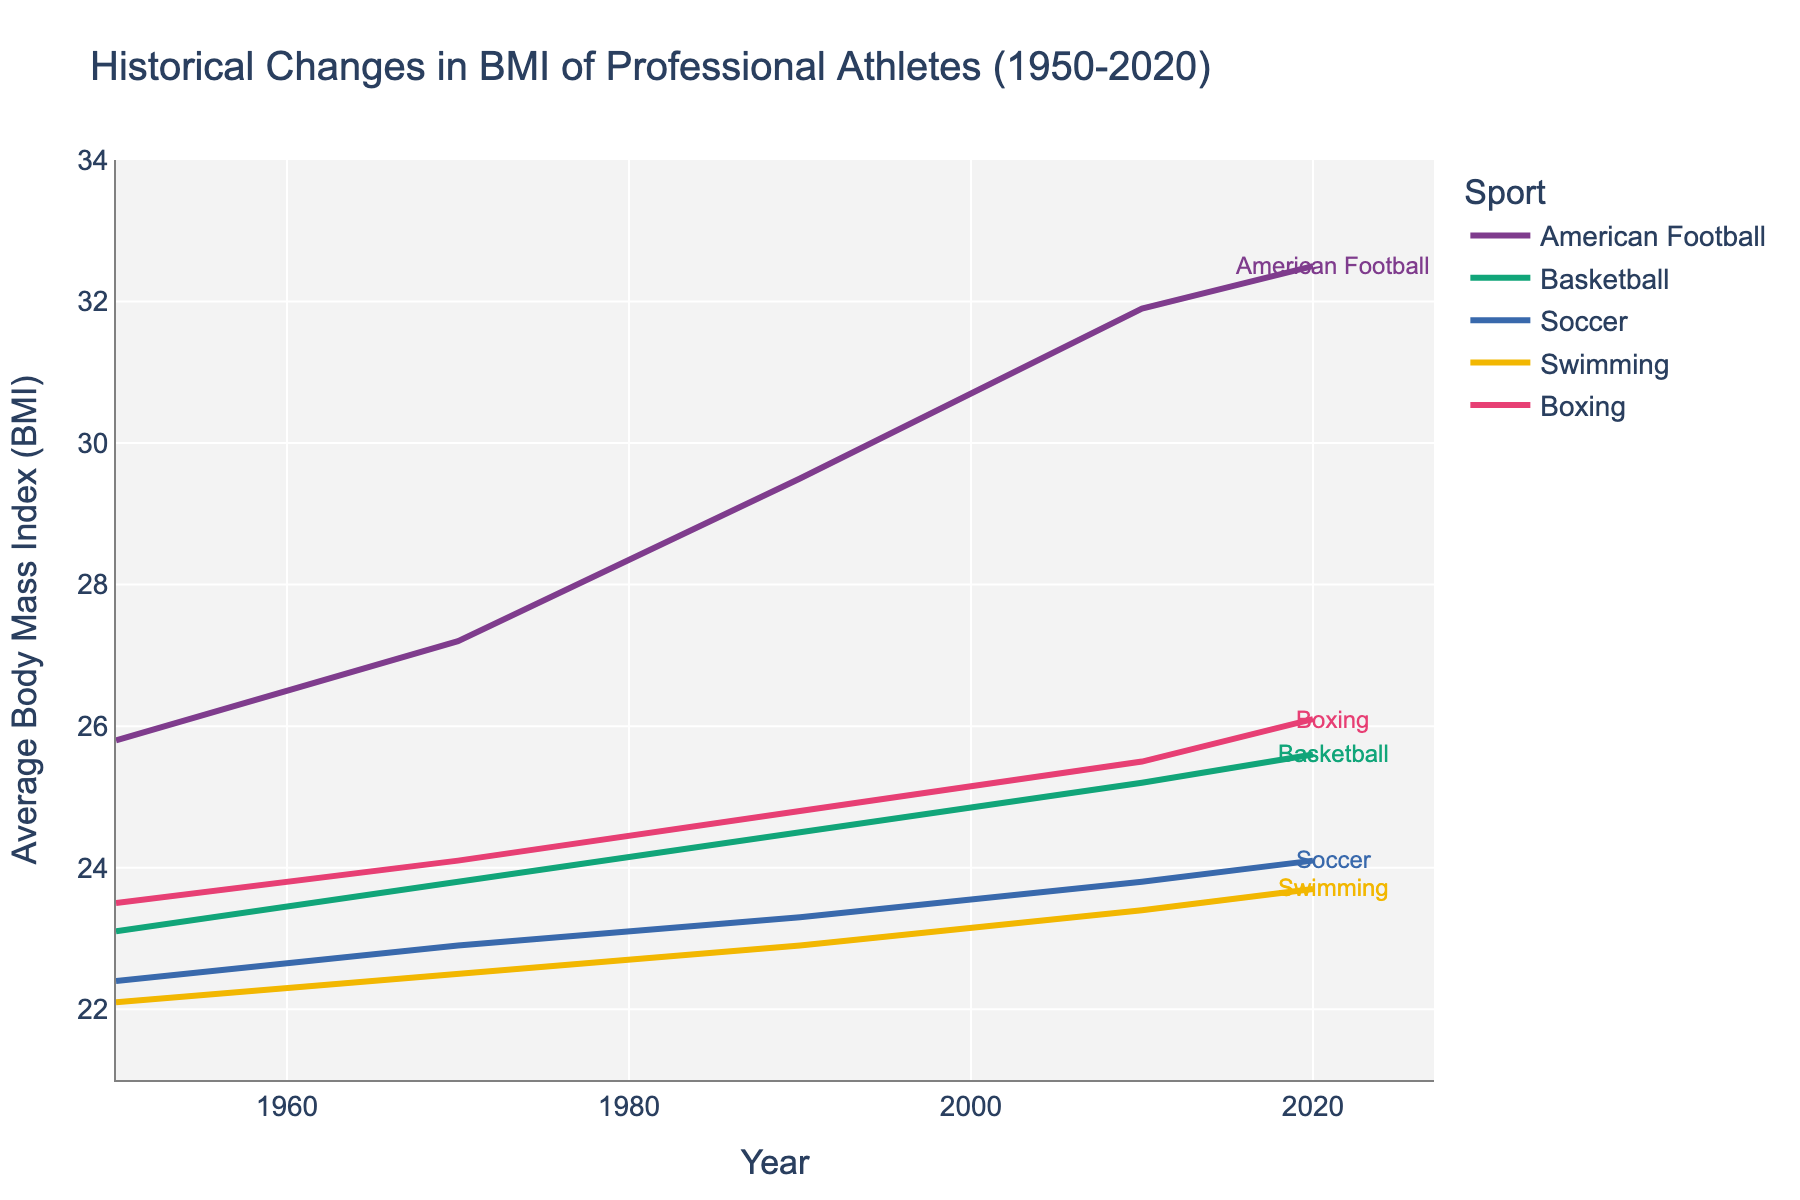What's the sport with the highest average BMI in 2020? To find the sport with the highest average BMI in 2020, follow the line for each sport to the year 2020 and compare the values. American Football has the highest BMI.
Answer: American Football How did the average BMI of professional boxers change from 1950 to 2020? Look at the points for Boxing in 1950 and 2020 and find the difference. The value increases from 23.5 in 1950 to 26.1 in 2020, so the change is 26.1 - 23.5 = 2.6.
Answer: 2.6 Which sport had the smallest increase in average BMI from 1950 to 2020? Calculate the increase for each sport by subtracting the 1950 BMI from the 2020 BMI. Swimming has the smallest increase (23.7 - 22.1 = 1.6).
Answer: Swimming Compare the basketball and soccer average BMIs in 1990. Which is higher? Find the average BMI for Basketball and Soccer in 1990 and compare them: Basketball has 24.5, and Soccer has 23.3. Basketball's average BMI is higher.
Answer: Basketball What is the overall trend in average BMI for American football from 1950 to 2020? Observe the American Football line from 1950 to 2020. The trend shows a steady increase in average BMI over time. The BMI rises from 25.8 in 1950 to 32.5 in 2020.
Answer: Increasing Which sport's average BMI increased at the slowest rate between 2010 and 2020? Calculate the rate of increase for each sport from 2010 to 2020 by subtracting the 2010 BMI from the 2020 BMI. Swimming has the smallest increase (23.7 - 23.4 = 0.3).
Answer: Swimming What was the average BMI for swimmers in 2010? Look at the data point for Swimming in the year 2010. The average BMI is 23.4.
Answer: 23.4 In which decade did American football athletes experience the largest jump in average BMI? Compare the decade-to-decade changes in BMI for American Football. The largest jump is from 1970 to 1990, where BMI increased from 27.2 to 29.5 (a difference of 2.3).
Answer: 1970 to 1990 